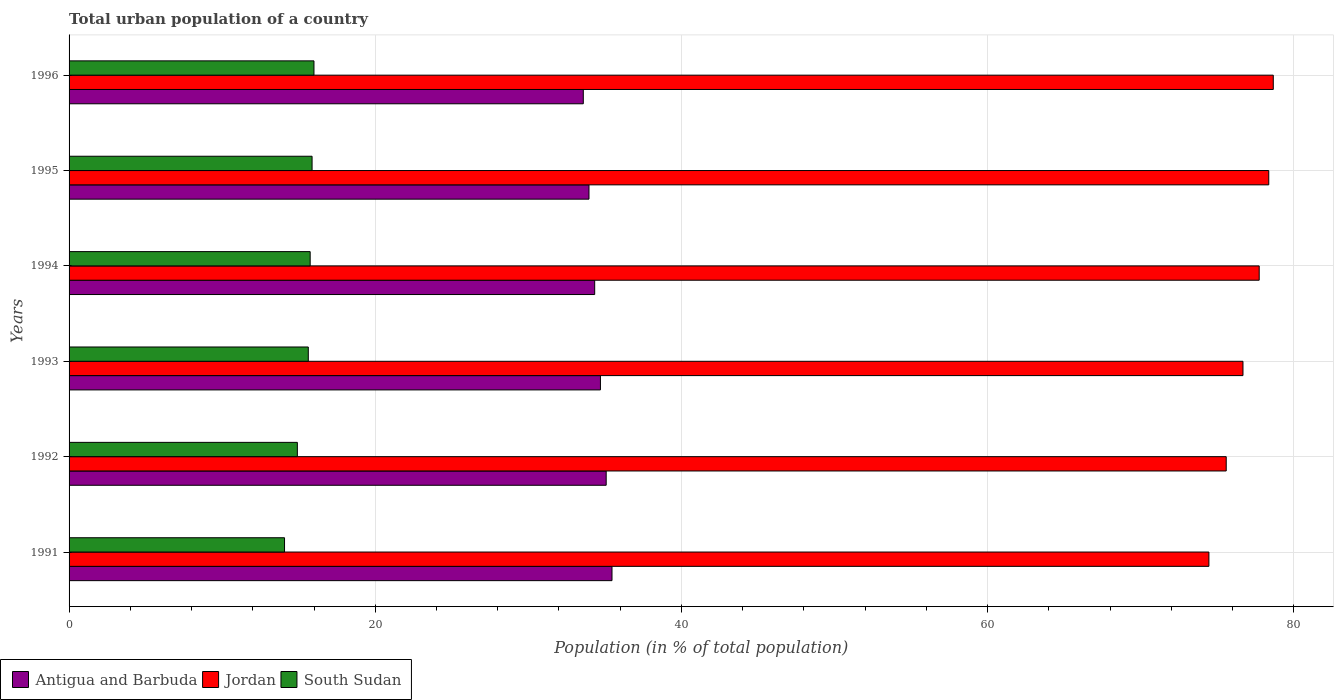How many groups of bars are there?
Give a very brief answer. 6. Are the number of bars per tick equal to the number of legend labels?
Your answer should be compact. Yes. Are the number of bars on each tick of the Y-axis equal?
Give a very brief answer. Yes. How many bars are there on the 1st tick from the top?
Your answer should be compact. 3. What is the label of the 5th group of bars from the top?
Ensure brevity in your answer.  1992. What is the urban population in Jordan in 1996?
Your answer should be compact. 78.66. Across all years, what is the maximum urban population in South Sudan?
Offer a terse response. 16. Across all years, what is the minimum urban population in South Sudan?
Keep it short and to the point. 14.07. In which year was the urban population in Jordan maximum?
Your answer should be compact. 1996. In which year was the urban population in Antigua and Barbuda minimum?
Ensure brevity in your answer.  1996. What is the total urban population in Jordan in the graph?
Keep it short and to the point. 461.49. What is the difference between the urban population in South Sudan in 1992 and that in 1994?
Your answer should be very brief. -0.84. What is the difference between the urban population in South Sudan in 1994 and the urban population in Jordan in 1992?
Make the answer very short. -59.84. What is the average urban population in South Sudan per year?
Provide a succinct answer. 15.37. In the year 1995, what is the difference between the urban population in Jordan and urban population in Antigua and Barbuda?
Make the answer very short. 44.4. In how many years, is the urban population in Jordan greater than 8 %?
Your response must be concise. 6. What is the ratio of the urban population in Jordan in 1991 to that in 1992?
Provide a short and direct response. 0.99. Is the urban population in Antigua and Barbuda in 1992 less than that in 1996?
Provide a short and direct response. No. What is the difference between the highest and the second highest urban population in Jordan?
Give a very brief answer. 0.3. What is the difference between the highest and the lowest urban population in South Sudan?
Your answer should be compact. 1.92. What does the 2nd bar from the top in 1996 represents?
Your answer should be very brief. Jordan. What does the 3rd bar from the bottom in 1992 represents?
Your response must be concise. South Sudan. How many bars are there?
Make the answer very short. 18. Are all the bars in the graph horizontal?
Offer a very short reply. Yes. Are the values on the major ticks of X-axis written in scientific E-notation?
Provide a succinct answer. No. Does the graph contain grids?
Your answer should be very brief. Yes. How many legend labels are there?
Offer a very short reply. 3. How are the legend labels stacked?
Provide a succinct answer. Horizontal. What is the title of the graph?
Keep it short and to the point. Total urban population of a country. Does "Northern Mariana Islands" appear as one of the legend labels in the graph?
Your answer should be compact. No. What is the label or title of the X-axis?
Ensure brevity in your answer.  Population (in % of total population). What is the Population (in % of total population) in Antigua and Barbuda in 1991?
Provide a short and direct response. 35.47. What is the Population (in % of total population) in Jordan in 1991?
Your response must be concise. 74.45. What is the Population (in % of total population) of South Sudan in 1991?
Your answer should be compact. 14.07. What is the Population (in % of total population) in Antigua and Barbuda in 1992?
Ensure brevity in your answer.  35.09. What is the Population (in % of total population) of Jordan in 1992?
Make the answer very short. 75.59. What is the Population (in % of total population) of South Sudan in 1992?
Your answer should be compact. 14.91. What is the Population (in % of total population) in Antigua and Barbuda in 1993?
Ensure brevity in your answer.  34.71. What is the Population (in % of total population) of Jordan in 1993?
Your answer should be very brief. 76.68. What is the Population (in % of total population) in South Sudan in 1993?
Provide a short and direct response. 15.63. What is the Population (in % of total population) in Antigua and Barbuda in 1994?
Offer a very short reply. 34.33. What is the Population (in % of total population) of Jordan in 1994?
Give a very brief answer. 77.74. What is the Population (in % of total population) in South Sudan in 1994?
Offer a very short reply. 15.75. What is the Population (in % of total population) of Antigua and Barbuda in 1995?
Keep it short and to the point. 33.96. What is the Population (in % of total population) in Jordan in 1995?
Ensure brevity in your answer.  78.36. What is the Population (in % of total population) of South Sudan in 1995?
Your answer should be compact. 15.87. What is the Population (in % of total population) of Antigua and Barbuda in 1996?
Offer a very short reply. 33.59. What is the Population (in % of total population) of Jordan in 1996?
Your answer should be very brief. 78.66. What is the Population (in % of total population) of South Sudan in 1996?
Offer a very short reply. 16. Across all years, what is the maximum Population (in % of total population) of Antigua and Barbuda?
Ensure brevity in your answer.  35.47. Across all years, what is the maximum Population (in % of total population) in Jordan?
Offer a very short reply. 78.66. Across all years, what is the maximum Population (in % of total population) in South Sudan?
Provide a short and direct response. 16. Across all years, what is the minimum Population (in % of total population) of Antigua and Barbuda?
Keep it short and to the point. 33.59. Across all years, what is the minimum Population (in % of total population) of Jordan?
Your response must be concise. 74.45. Across all years, what is the minimum Population (in % of total population) in South Sudan?
Make the answer very short. 14.07. What is the total Population (in % of total population) in Antigua and Barbuda in the graph?
Offer a very short reply. 207.14. What is the total Population (in % of total population) of Jordan in the graph?
Make the answer very short. 461.49. What is the total Population (in % of total population) of South Sudan in the graph?
Provide a short and direct response. 92.23. What is the difference between the Population (in % of total population) in Antigua and Barbuda in 1991 and that in 1992?
Provide a short and direct response. 0.38. What is the difference between the Population (in % of total population) in Jordan in 1991 and that in 1992?
Your response must be concise. -1.13. What is the difference between the Population (in % of total population) in South Sudan in 1991 and that in 1992?
Offer a very short reply. -0.84. What is the difference between the Population (in % of total population) of Antigua and Barbuda in 1991 and that in 1993?
Your answer should be very brief. 0.76. What is the difference between the Population (in % of total population) of Jordan in 1991 and that in 1993?
Your answer should be compact. -2.23. What is the difference between the Population (in % of total population) in South Sudan in 1991 and that in 1993?
Keep it short and to the point. -1.55. What is the difference between the Population (in % of total population) in Antigua and Barbuda in 1991 and that in 1994?
Your response must be concise. 1.13. What is the difference between the Population (in % of total population) of Jordan in 1991 and that in 1994?
Offer a terse response. -3.29. What is the difference between the Population (in % of total population) of South Sudan in 1991 and that in 1994?
Give a very brief answer. -1.68. What is the difference between the Population (in % of total population) in Antigua and Barbuda in 1991 and that in 1995?
Provide a succinct answer. 1.5. What is the difference between the Population (in % of total population) in Jordan in 1991 and that in 1995?
Your answer should be very brief. -3.91. What is the difference between the Population (in % of total population) of South Sudan in 1991 and that in 1995?
Ensure brevity in your answer.  -1.8. What is the difference between the Population (in % of total population) of Antigua and Barbuda in 1991 and that in 1996?
Offer a very short reply. 1.88. What is the difference between the Population (in % of total population) in Jordan in 1991 and that in 1996?
Your answer should be compact. -4.21. What is the difference between the Population (in % of total population) of South Sudan in 1991 and that in 1996?
Give a very brief answer. -1.92. What is the difference between the Population (in % of total population) of Antigua and Barbuda in 1992 and that in 1993?
Offer a terse response. 0.38. What is the difference between the Population (in % of total population) in Jordan in 1992 and that in 1993?
Offer a very short reply. -1.09. What is the difference between the Population (in % of total population) in South Sudan in 1992 and that in 1993?
Give a very brief answer. -0.71. What is the difference between the Population (in % of total population) in Antigua and Barbuda in 1992 and that in 1994?
Offer a terse response. 0.75. What is the difference between the Population (in % of total population) in Jordan in 1992 and that in 1994?
Offer a terse response. -2.15. What is the difference between the Population (in % of total population) of South Sudan in 1992 and that in 1994?
Ensure brevity in your answer.  -0.84. What is the difference between the Population (in % of total population) of Antigua and Barbuda in 1992 and that in 1995?
Make the answer very short. 1.12. What is the difference between the Population (in % of total population) in Jordan in 1992 and that in 1995?
Your answer should be compact. -2.78. What is the difference between the Population (in % of total population) in South Sudan in 1992 and that in 1995?
Offer a very short reply. -0.96. What is the difference between the Population (in % of total population) in Antigua and Barbuda in 1992 and that in 1996?
Give a very brief answer. 1.5. What is the difference between the Population (in % of total population) of Jordan in 1992 and that in 1996?
Offer a very short reply. -3.07. What is the difference between the Population (in % of total population) of South Sudan in 1992 and that in 1996?
Give a very brief answer. -1.08. What is the difference between the Population (in % of total population) in Jordan in 1993 and that in 1994?
Provide a succinct answer. -1.06. What is the difference between the Population (in % of total population) in South Sudan in 1993 and that in 1994?
Your response must be concise. -0.12. What is the difference between the Population (in % of total population) in Antigua and Barbuda in 1993 and that in 1995?
Give a very brief answer. 0.75. What is the difference between the Population (in % of total population) of Jordan in 1993 and that in 1995?
Offer a terse response. -1.69. What is the difference between the Population (in % of total population) of South Sudan in 1993 and that in 1995?
Your response must be concise. -0.25. What is the difference between the Population (in % of total population) of Antigua and Barbuda in 1993 and that in 1996?
Your answer should be compact. 1.12. What is the difference between the Population (in % of total population) in Jordan in 1993 and that in 1996?
Keep it short and to the point. -1.98. What is the difference between the Population (in % of total population) in South Sudan in 1993 and that in 1996?
Provide a succinct answer. -0.37. What is the difference between the Population (in % of total population) in Antigua and Barbuda in 1994 and that in 1995?
Keep it short and to the point. 0.37. What is the difference between the Population (in % of total population) of Jordan in 1994 and that in 1995?
Keep it short and to the point. -0.62. What is the difference between the Population (in % of total population) of South Sudan in 1994 and that in 1995?
Offer a terse response. -0.12. What is the difference between the Population (in % of total population) in Antigua and Barbuda in 1994 and that in 1996?
Give a very brief answer. 0.74. What is the difference between the Population (in % of total population) in Jordan in 1994 and that in 1996?
Give a very brief answer. -0.92. What is the difference between the Population (in % of total population) in South Sudan in 1994 and that in 1996?
Offer a very short reply. -0.25. What is the difference between the Population (in % of total population) of Antigua and Barbuda in 1995 and that in 1996?
Your answer should be compact. 0.37. What is the difference between the Population (in % of total population) of Jordan in 1995 and that in 1996?
Offer a terse response. -0.29. What is the difference between the Population (in % of total population) of South Sudan in 1995 and that in 1996?
Your answer should be very brief. -0.12. What is the difference between the Population (in % of total population) in Antigua and Barbuda in 1991 and the Population (in % of total population) in Jordan in 1992?
Offer a very short reply. -40.12. What is the difference between the Population (in % of total population) of Antigua and Barbuda in 1991 and the Population (in % of total population) of South Sudan in 1992?
Your response must be concise. 20.55. What is the difference between the Population (in % of total population) of Jordan in 1991 and the Population (in % of total population) of South Sudan in 1992?
Your answer should be very brief. 59.54. What is the difference between the Population (in % of total population) of Antigua and Barbuda in 1991 and the Population (in % of total population) of Jordan in 1993?
Provide a short and direct response. -41.22. What is the difference between the Population (in % of total population) in Antigua and Barbuda in 1991 and the Population (in % of total population) in South Sudan in 1993?
Your answer should be compact. 19.84. What is the difference between the Population (in % of total population) of Jordan in 1991 and the Population (in % of total population) of South Sudan in 1993?
Your answer should be compact. 58.83. What is the difference between the Population (in % of total population) in Antigua and Barbuda in 1991 and the Population (in % of total population) in Jordan in 1994?
Offer a very short reply. -42.27. What is the difference between the Population (in % of total population) of Antigua and Barbuda in 1991 and the Population (in % of total population) of South Sudan in 1994?
Your answer should be very brief. 19.72. What is the difference between the Population (in % of total population) of Jordan in 1991 and the Population (in % of total population) of South Sudan in 1994?
Make the answer very short. 58.71. What is the difference between the Population (in % of total population) of Antigua and Barbuda in 1991 and the Population (in % of total population) of Jordan in 1995?
Provide a succinct answer. -42.9. What is the difference between the Population (in % of total population) of Antigua and Barbuda in 1991 and the Population (in % of total population) of South Sudan in 1995?
Provide a short and direct response. 19.59. What is the difference between the Population (in % of total population) of Jordan in 1991 and the Population (in % of total population) of South Sudan in 1995?
Make the answer very short. 58.58. What is the difference between the Population (in % of total population) in Antigua and Barbuda in 1991 and the Population (in % of total population) in Jordan in 1996?
Offer a terse response. -43.2. What is the difference between the Population (in % of total population) in Antigua and Barbuda in 1991 and the Population (in % of total population) in South Sudan in 1996?
Your response must be concise. 19.47. What is the difference between the Population (in % of total population) of Jordan in 1991 and the Population (in % of total population) of South Sudan in 1996?
Ensure brevity in your answer.  58.46. What is the difference between the Population (in % of total population) in Antigua and Barbuda in 1992 and the Population (in % of total population) in Jordan in 1993?
Offer a terse response. -41.59. What is the difference between the Population (in % of total population) of Antigua and Barbuda in 1992 and the Population (in % of total population) of South Sudan in 1993?
Make the answer very short. 19.46. What is the difference between the Population (in % of total population) of Jordan in 1992 and the Population (in % of total population) of South Sudan in 1993?
Keep it short and to the point. 59.96. What is the difference between the Population (in % of total population) of Antigua and Barbuda in 1992 and the Population (in % of total population) of Jordan in 1994?
Provide a succinct answer. -42.66. What is the difference between the Population (in % of total population) of Antigua and Barbuda in 1992 and the Population (in % of total population) of South Sudan in 1994?
Offer a terse response. 19.34. What is the difference between the Population (in % of total population) of Jordan in 1992 and the Population (in % of total population) of South Sudan in 1994?
Make the answer very short. 59.84. What is the difference between the Population (in % of total population) in Antigua and Barbuda in 1992 and the Population (in % of total population) in Jordan in 1995?
Offer a terse response. -43.28. What is the difference between the Population (in % of total population) in Antigua and Barbuda in 1992 and the Population (in % of total population) in South Sudan in 1995?
Your answer should be compact. 19.21. What is the difference between the Population (in % of total population) of Jordan in 1992 and the Population (in % of total population) of South Sudan in 1995?
Your answer should be compact. 59.71. What is the difference between the Population (in % of total population) of Antigua and Barbuda in 1992 and the Population (in % of total population) of Jordan in 1996?
Offer a terse response. -43.58. What is the difference between the Population (in % of total population) in Antigua and Barbuda in 1992 and the Population (in % of total population) in South Sudan in 1996?
Make the answer very short. 19.09. What is the difference between the Population (in % of total population) in Jordan in 1992 and the Population (in % of total population) in South Sudan in 1996?
Make the answer very short. 59.59. What is the difference between the Population (in % of total population) in Antigua and Barbuda in 1993 and the Population (in % of total population) in Jordan in 1994?
Offer a very short reply. -43.03. What is the difference between the Population (in % of total population) in Antigua and Barbuda in 1993 and the Population (in % of total population) in South Sudan in 1994?
Offer a terse response. 18.96. What is the difference between the Population (in % of total population) in Jordan in 1993 and the Population (in % of total population) in South Sudan in 1994?
Your response must be concise. 60.93. What is the difference between the Population (in % of total population) of Antigua and Barbuda in 1993 and the Population (in % of total population) of Jordan in 1995?
Your response must be concise. -43.66. What is the difference between the Population (in % of total population) of Antigua and Barbuda in 1993 and the Population (in % of total population) of South Sudan in 1995?
Provide a short and direct response. 18.84. What is the difference between the Population (in % of total population) in Jordan in 1993 and the Population (in % of total population) in South Sudan in 1995?
Offer a terse response. 60.81. What is the difference between the Population (in % of total population) of Antigua and Barbuda in 1993 and the Population (in % of total population) of Jordan in 1996?
Your response must be concise. -43.95. What is the difference between the Population (in % of total population) of Antigua and Barbuda in 1993 and the Population (in % of total population) of South Sudan in 1996?
Give a very brief answer. 18.71. What is the difference between the Population (in % of total population) in Jordan in 1993 and the Population (in % of total population) in South Sudan in 1996?
Offer a very short reply. 60.68. What is the difference between the Population (in % of total population) of Antigua and Barbuda in 1994 and the Population (in % of total population) of Jordan in 1995?
Ensure brevity in your answer.  -44.03. What is the difference between the Population (in % of total population) of Antigua and Barbuda in 1994 and the Population (in % of total population) of South Sudan in 1995?
Provide a short and direct response. 18.46. What is the difference between the Population (in % of total population) of Jordan in 1994 and the Population (in % of total population) of South Sudan in 1995?
Provide a succinct answer. 61.87. What is the difference between the Population (in % of total population) in Antigua and Barbuda in 1994 and the Population (in % of total population) in Jordan in 1996?
Your response must be concise. -44.33. What is the difference between the Population (in % of total population) of Antigua and Barbuda in 1994 and the Population (in % of total population) of South Sudan in 1996?
Your answer should be compact. 18.34. What is the difference between the Population (in % of total population) of Jordan in 1994 and the Population (in % of total population) of South Sudan in 1996?
Make the answer very short. 61.74. What is the difference between the Population (in % of total population) of Antigua and Barbuda in 1995 and the Population (in % of total population) of Jordan in 1996?
Your response must be concise. -44.7. What is the difference between the Population (in % of total population) of Antigua and Barbuda in 1995 and the Population (in % of total population) of South Sudan in 1996?
Give a very brief answer. 17.96. What is the difference between the Population (in % of total population) of Jordan in 1995 and the Population (in % of total population) of South Sudan in 1996?
Provide a succinct answer. 62.37. What is the average Population (in % of total population) of Antigua and Barbuda per year?
Keep it short and to the point. 34.52. What is the average Population (in % of total population) of Jordan per year?
Provide a succinct answer. 76.91. What is the average Population (in % of total population) of South Sudan per year?
Your answer should be very brief. 15.37. In the year 1991, what is the difference between the Population (in % of total population) in Antigua and Barbuda and Population (in % of total population) in Jordan?
Provide a short and direct response. -38.99. In the year 1991, what is the difference between the Population (in % of total population) in Antigua and Barbuda and Population (in % of total population) in South Sudan?
Make the answer very short. 21.39. In the year 1991, what is the difference between the Population (in % of total population) in Jordan and Population (in % of total population) in South Sudan?
Offer a terse response. 60.38. In the year 1992, what is the difference between the Population (in % of total population) of Antigua and Barbuda and Population (in % of total population) of Jordan?
Offer a very short reply. -40.5. In the year 1992, what is the difference between the Population (in % of total population) of Antigua and Barbuda and Population (in % of total population) of South Sudan?
Offer a very short reply. 20.17. In the year 1992, what is the difference between the Population (in % of total population) in Jordan and Population (in % of total population) in South Sudan?
Keep it short and to the point. 60.67. In the year 1993, what is the difference between the Population (in % of total population) in Antigua and Barbuda and Population (in % of total population) in Jordan?
Keep it short and to the point. -41.97. In the year 1993, what is the difference between the Population (in % of total population) in Antigua and Barbuda and Population (in % of total population) in South Sudan?
Provide a short and direct response. 19.08. In the year 1993, what is the difference between the Population (in % of total population) of Jordan and Population (in % of total population) of South Sudan?
Your answer should be compact. 61.05. In the year 1994, what is the difference between the Population (in % of total population) in Antigua and Barbuda and Population (in % of total population) in Jordan?
Make the answer very short. -43.41. In the year 1994, what is the difference between the Population (in % of total population) in Antigua and Barbuda and Population (in % of total population) in South Sudan?
Keep it short and to the point. 18.59. In the year 1994, what is the difference between the Population (in % of total population) in Jordan and Population (in % of total population) in South Sudan?
Provide a succinct answer. 61.99. In the year 1995, what is the difference between the Population (in % of total population) in Antigua and Barbuda and Population (in % of total population) in Jordan?
Keep it short and to the point. -44.4. In the year 1995, what is the difference between the Population (in % of total population) in Antigua and Barbuda and Population (in % of total population) in South Sudan?
Offer a terse response. 18.09. In the year 1995, what is the difference between the Population (in % of total population) of Jordan and Population (in % of total population) of South Sudan?
Offer a terse response. 62.49. In the year 1996, what is the difference between the Population (in % of total population) of Antigua and Barbuda and Population (in % of total population) of Jordan?
Keep it short and to the point. -45.07. In the year 1996, what is the difference between the Population (in % of total population) of Antigua and Barbuda and Population (in % of total population) of South Sudan?
Provide a succinct answer. 17.59. In the year 1996, what is the difference between the Population (in % of total population) of Jordan and Population (in % of total population) of South Sudan?
Give a very brief answer. 62.66. What is the ratio of the Population (in % of total population) in Antigua and Barbuda in 1991 to that in 1992?
Make the answer very short. 1.01. What is the ratio of the Population (in % of total population) of South Sudan in 1991 to that in 1992?
Provide a short and direct response. 0.94. What is the ratio of the Population (in % of total population) of Antigua and Barbuda in 1991 to that in 1993?
Offer a terse response. 1.02. What is the ratio of the Population (in % of total population) in Jordan in 1991 to that in 1993?
Offer a very short reply. 0.97. What is the ratio of the Population (in % of total population) of South Sudan in 1991 to that in 1993?
Keep it short and to the point. 0.9. What is the ratio of the Population (in % of total population) in Antigua and Barbuda in 1991 to that in 1994?
Provide a short and direct response. 1.03. What is the ratio of the Population (in % of total population) in Jordan in 1991 to that in 1994?
Give a very brief answer. 0.96. What is the ratio of the Population (in % of total population) in South Sudan in 1991 to that in 1994?
Your answer should be very brief. 0.89. What is the ratio of the Population (in % of total population) in Antigua and Barbuda in 1991 to that in 1995?
Keep it short and to the point. 1.04. What is the ratio of the Population (in % of total population) of Jordan in 1991 to that in 1995?
Make the answer very short. 0.95. What is the ratio of the Population (in % of total population) in South Sudan in 1991 to that in 1995?
Offer a terse response. 0.89. What is the ratio of the Population (in % of total population) in Antigua and Barbuda in 1991 to that in 1996?
Offer a terse response. 1.06. What is the ratio of the Population (in % of total population) in Jordan in 1991 to that in 1996?
Offer a terse response. 0.95. What is the ratio of the Population (in % of total population) in South Sudan in 1991 to that in 1996?
Offer a terse response. 0.88. What is the ratio of the Population (in % of total population) of Antigua and Barbuda in 1992 to that in 1993?
Ensure brevity in your answer.  1.01. What is the ratio of the Population (in % of total population) of Jordan in 1992 to that in 1993?
Provide a succinct answer. 0.99. What is the ratio of the Population (in % of total population) of South Sudan in 1992 to that in 1993?
Give a very brief answer. 0.95. What is the ratio of the Population (in % of total population) in Antigua and Barbuda in 1992 to that in 1994?
Keep it short and to the point. 1.02. What is the ratio of the Population (in % of total population) of Jordan in 1992 to that in 1994?
Make the answer very short. 0.97. What is the ratio of the Population (in % of total population) in South Sudan in 1992 to that in 1994?
Keep it short and to the point. 0.95. What is the ratio of the Population (in % of total population) in Antigua and Barbuda in 1992 to that in 1995?
Make the answer very short. 1.03. What is the ratio of the Population (in % of total population) in Jordan in 1992 to that in 1995?
Provide a succinct answer. 0.96. What is the ratio of the Population (in % of total population) in South Sudan in 1992 to that in 1995?
Offer a very short reply. 0.94. What is the ratio of the Population (in % of total population) in Antigua and Barbuda in 1992 to that in 1996?
Offer a very short reply. 1.04. What is the ratio of the Population (in % of total population) of Jordan in 1992 to that in 1996?
Your response must be concise. 0.96. What is the ratio of the Population (in % of total population) of South Sudan in 1992 to that in 1996?
Give a very brief answer. 0.93. What is the ratio of the Population (in % of total population) in Antigua and Barbuda in 1993 to that in 1994?
Offer a terse response. 1.01. What is the ratio of the Population (in % of total population) of Jordan in 1993 to that in 1994?
Give a very brief answer. 0.99. What is the ratio of the Population (in % of total population) of South Sudan in 1993 to that in 1994?
Provide a succinct answer. 0.99. What is the ratio of the Population (in % of total population) in Antigua and Barbuda in 1993 to that in 1995?
Provide a succinct answer. 1.02. What is the ratio of the Population (in % of total population) of Jordan in 1993 to that in 1995?
Your answer should be very brief. 0.98. What is the ratio of the Population (in % of total population) in South Sudan in 1993 to that in 1995?
Provide a short and direct response. 0.98. What is the ratio of the Population (in % of total population) in Antigua and Barbuda in 1993 to that in 1996?
Provide a succinct answer. 1.03. What is the ratio of the Population (in % of total population) in Jordan in 1993 to that in 1996?
Provide a short and direct response. 0.97. What is the ratio of the Population (in % of total population) of South Sudan in 1993 to that in 1996?
Your answer should be very brief. 0.98. What is the ratio of the Population (in % of total population) in Antigua and Barbuda in 1994 to that in 1995?
Offer a very short reply. 1.01. What is the ratio of the Population (in % of total population) in Jordan in 1994 to that in 1995?
Offer a terse response. 0.99. What is the ratio of the Population (in % of total population) of Antigua and Barbuda in 1994 to that in 1996?
Provide a short and direct response. 1.02. What is the ratio of the Population (in % of total population) of Jordan in 1994 to that in 1996?
Provide a succinct answer. 0.99. What is the ratio of the Population (in % of total population) of South Sudan in 1994 to that in 1996?
Your answer should be compact. 0.98. What is the ratio of the Population (in % of total population) in Antigua and Barbuda in 1995 to that in 1996?
Keep it short and to the point. 1.01. What is the difference between the highest and the second highest Population (in % of total population) in Antigua and Barbuda?
Offer a very short reply. 0.38. What is the difference between the highest and the second highest Population (in % of total population) of Jordan?
Your answer should be compact. 0.29. What is the difference between the highest and the second highest Population (in % of total population) of South Sudan?
Offer a very short reply. 0.12. What is the difference between the highest and the lowest Population (in % of total population) in Antigua and Barbuda?
Give a very brief answer. 1.88. What is the difference between the highest and the lowest Population (in % of total population) of Jordan?
Make the answer very short. 4.21. What is the difference between the highest and the lowest Population (in % of total population) in South Sudan?
Your response must be concise. 1.92. 